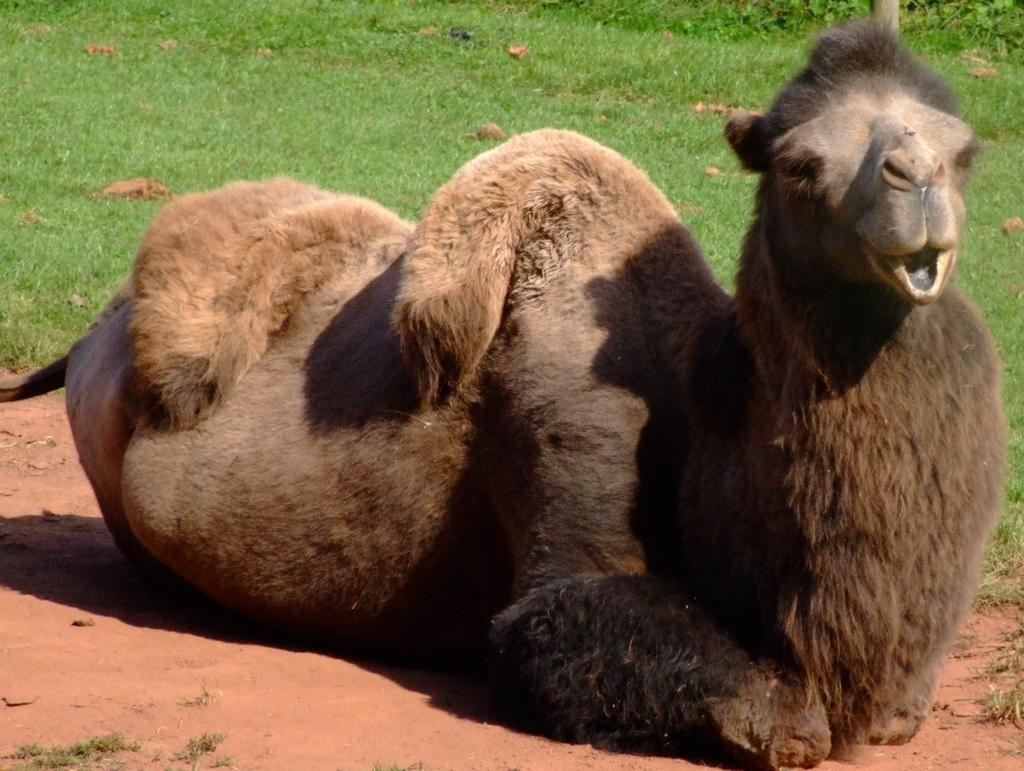What animal is on the ground in the image? There is a camel on the ground in the image. What type of vegetation can be seen in the background of the image? There is grass and plants in the background of the image. What other object is visible in the background of the image? There is a pole in the background of the image. What is the tendency of the gold to shine in the image? There is no gold present in the image, so its tendency to shine cannot be determined. 